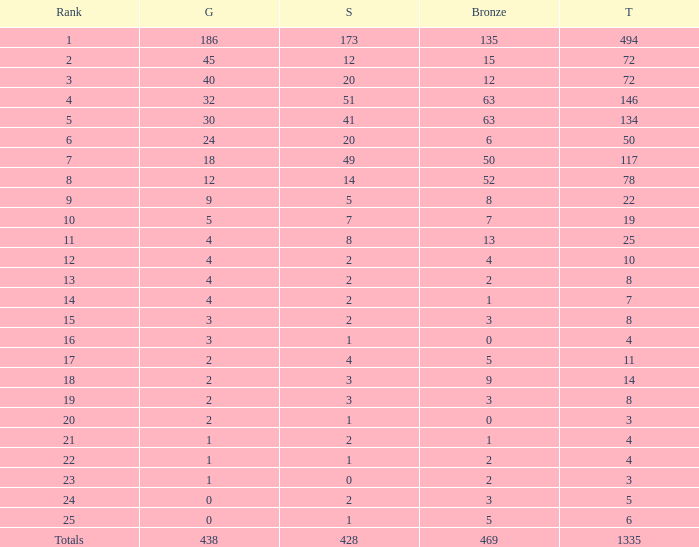I'm looking to parse the entire table for insights. Could you assist me with that? {'header': ['Rank', 'G', 'S', 'Bronze', 'T'], 'rows': [['1', '186', '173', '135', '494'], ['2', '45', '12', '15', '72'], ['3', '40', '20', '12', '72'], ['4', '32', '51', '63', '146'], ['5', '30', '41', '63', '134'], ['6', '24', '20', '6', '50'], ['7', '18', '49', '50', '117'], ['8', '12', '14', '52', '78'], ['9', '9', '5', '8', '22'], ['10', '5', '7', '7', '19'], ['11', '4', '8', '13', '25'], ['12', '4', '2', '4', '10'], ['13', '4', '2', '2', '8'], ['14', '4', '2', '1', '7'], ['15', '3', '2', '3', '8'], ['16', '3', '1', '0', '4'], ['17', '2', '4', '5', '11'], ['18', '2', '3', '9', '14'], ['19', '2', '3', '3', '8'], ['20', '2', '1', '0', '3'], ['21', '1', '2', '1', '4'], ['22', '1', '1', '2', '4'], ['23', '1', '0', '2', '3'], ['24', '0', '2', '3', '5'], ['25', '0', '1', '5', '6'], ['Totals', '438', '428', '469', '1335']]} What is the average number of gold medals when the total was 1335 medals, with more than 469 bronzes and more than 14 silvers? None. 